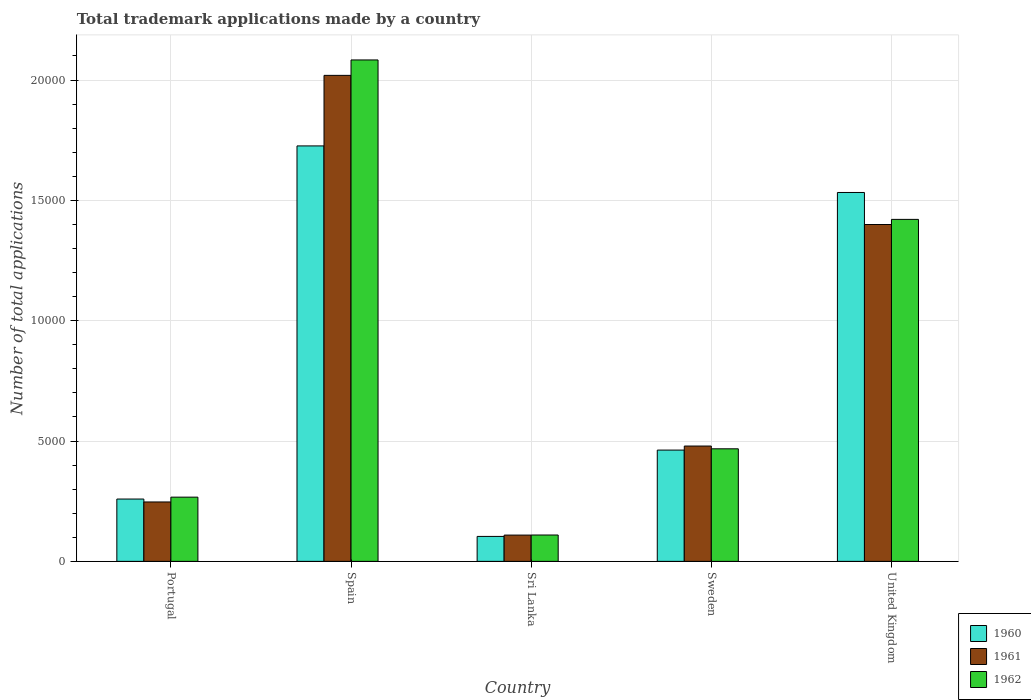Are the number of bars per tick equal to the number of legend labels?
Offer a terse response. Yes. Are the number of bars on each tick of the X-axis equal?
Your response must be concise. Yes. How many bars are there on the 2nd tick from the left?
Make the answer very short. 3. How many bars are there on the 1st tick from the right?
Ensure brevity in your answer.  3. What is the label of the 4th group of bars from the left?
Ensure brevity in your answer.  Sweden. In how many cases, is the number of bars for a given country not equal to the number of legend labels?
Your answer should be compact. 0. What is the number of applications made by in 1960 in Spain?
Keep it short and to the point. 1.73e+04. Across all countries, what is the maximum number of applications made by in 1961?
Your response must be concise. 2.02e+04. Across all countries, what is the minimum number of applications made by in 1962?
Provide a succinct answer. 1095. In which country was the number of applications made by in 1962 minimum?
Provide a short and direct response. Sri Lanka. What is the total number of applications made by in 1962 in the graph?
Offer a terse response. 4.35e+04. What is the difference between the number of applications made by in 1961 in Portugal and that in Spain?
Your answer should be very brief. -1.77e+04. What is the difference between the number of applications made by in 1960 in Sri Lanka and the number of applications made by in 1962 in United Kingdom?
Your answer should be very brief. -1.32e+04. What is the average number of applications made by in 1962 per country?
Provide a short and direct response. 8697. What is the difference between the number of applications made by of/in 1960 and number of applications made by of/in 1961 in United Kingdom?
Your response must be concise. 1331. What is the ratio of the number of applications made by in 1960 in Spain to that in Sri Lanka?
Provide a short and direct response. 16.65. Is the number of applications made by in 1961 in Spain less than that in Sweden?
Provide a short and direct response. No. Is the difference between the number of applications made by in 1960 in Spain and Sri Lanka greater than the difference between the number of applications made by in 1961 in Spain and Sri Lanka?
Offer a terse response. No. What is the difference between the highest and the second highest number of applications made by in 1960?
Give a very brief answer. 1.07e+04. What is the difference between the highest and the lowest number of applications made by in 1960?
Offer a terse response. 1.62e+04. In how many countries, is the number of applications made by in 1962 greater than the average number of applications made by in 1962 taken over all countries?
Your answer should be compact. 2. What does the 2nd bar from the left in United Kingdom represents?
Provide a short and direct response. 1961. What does the 1st bar from the right in Sweden represents?
Make the answer very short. 1962. Is it the case that in every country, the sum of the number of applications made by in 1962 and number of applications made by in 1961 is greater than the number of applications made by in 1960?
Your answer should be very brief. Yes. Are all the bars in the graph horizontal?
Make the answer very short. No. How many countries are there in the graph?
Your answer should be compact. 5. What is the difference between two consecutive major ticks on the Y-axis?
Provide a short and direct response. 5000. Does the graph contain any zero values?
Your answer should be compact. No. Where does the legend appear in the graph?
Give a very brief answer. Bottom right. How many legend labels are there?
Keep it short and to the point. 3. How are the legend labels stacked?
Provide a succinct answer. Vertical. What is the title of the graph?
Your answer should be very brief. Total trademark applications made by a country. What is the label or title of the Y-axis?
Provide a succinct answer. Number of total applications. What is the Number of total applications of 1960 in Portugal?
Provide a succinct answer. 2590. What is the Number of total applications in 1961 in Portugal?
Offer a very short reply. 2468. What is the Number of total applications of 1962 in Portugal?
Provide a short and direct response. 2668. What is the Number of total applications of 1960 in Spain?
Provide a short and direct response. 1.73e+04. What is the Number of total applications of 1961 in Spain?
Make the answer very short. 2.02e+04. What is the Number of total applications of 1962 in Spain?
Keep it short and to the point. 2.08e+04. What is the Number of total applications of 1960 in Sri Lanka?
Offer a terse response. 1037. What is the Number of total applications of 1961 in Sri Lanka?
Your answer should be very brief. 1092. What is the Number of total applications in 1962 in Sri Lanka?
Your answer should be very brief. 1095. What is the Number of total applications of 1960 in Sweden?
Keep it short and to the point. 4624. What is the Number of total applications of 1961 in Sweden?
Give a very brief answer. 4792. What is the Number of total applications of 1962 in Sweden?
Keep it short and to the point. 4677. What is the Number of total applications of 1960 in United Kingdom?
Keep it short and to the point. 1.53e+04. What is the Number of total applications in 1961 in United Kingdom?
Give a very brief answer. 1.40e+04. What is the Number of total applications of 1962 in United Kingdom?
Your response must be concise. 1.42e+04. Across all countries, what is the maximum Number of total applications in 1960?
Give a very brief answer. 1.73e+04. Across all countries, what is the maximum Number of total applications of 1961?
Provide a short and direct response. 2.02e+04. Across all countries, what is the maximum Number of total applications in 1962?
Ensure brevity in your answer.  2.08e+04. Across all countries, what is the minimum Number of total applications of 1960?
Make the answer very short. 1037. Across all countries, what is the minimum Number of total applications in 1961?
Your answer should be compact. 1092. Across all countries, what is the minimum Number of total applications of 1962?
Keep it short and to the point. 1095. What is the total Number of total applications of 1960 in the graph?
Ensure brevity in your answer.  4.08e+04. What is the total Number of total applications of 1961 in the graph?
Make the answer very short. 4.25e+04. What is the total Number of total applications in 1962 in the graph?
Your response must be concise. 4.35e+04. What is the difference between the Number of total applications of 1960 in Portugal and that in Spain?
Offer a terse response. -1.47e+04. What is the difference between the Number of total applications in 1961 in Portugal and that in Spain?
Make the answer very short. -1.77e+04. What is the difference between the Number of total applications in 1962 in Portugal and that in Spain?
Keep it short and to the point. -1.82e+04. What is the difference between the Number of total applications of 1960 in Portugal and that in Sri Lanka?
Your response must be concise. 1553. What is the difference between the Number of total applications of 1961 in Portugal and that in Sri Lanka?
Keep it short and to the point. 1376. What is the difference between the Number of total applications in 1962 in Portugal and that in Sri Lanka?
Keep it short and to the point. 1573. What is the difference between the Number of total applications of 1960 in Portugal and that in Sweden?
Give a very brief answer. -2034. What is the difference between the Number of total applications in 1961 in Portugal and that in Sweden?
Keep it short and to the point. -2324. What is the difference between the Number of total applications of 1962 in Portugal and that in Sweden?
Provide a short and direct response. -2009. What is the difference between the Number of total applications of 1960 in Portugal and that in United Kingdom?
Provide a succinct answer. -1.27e+04. What is the difference between the Number of total applications of 1961 in Portugal and that in United Kingdom?
Give a very brief answer. -1.15e+04. What is the difference between the Number of total applications of 1962 in Portugal and that in United Kingdom?
Make the answer very short. -1.15e+04. What is the difference between the Number of total applications in 1960 in Spain and that in Sri Lanka?
Your response must be concise. 1.62e+04. What is the difference between the Number of total applications of 1961 in Spain and that in Sri Lanka?
Make the answer very short. 1.91e+04. What is the difference between the Number of total applications of 1962 in Spain and that in Sri Lanka?
Keep it short and to the point. 1.97e+04. What is the difference between the Number of total applications in 1960 in Spain and that in Sweden?
Offer a very short reply. 1.26e+04. What is the difference between the Number of total applications in 1961 in Spain and that in Sweden?
Ensure brevity in your answer.  1.54e+04. What is the difference between the Number of total applications in 1962 in Spain and that in Sweden?
Ensure brevity in your answer.  1.62e+04. What is the difference between the Number of total applications of 1960 in Spain and that in United Kingdom?
Your answer should be very brief. 1935. What is the difference between the Number of total applications in 1961 in Spain and that in United Kingdom?
Offer a very short reply. 6197. What is the difference between the Number of total applications of 1962 in Spain and that in United Kingdom?
Your response must be concise. 6625. What is the difference between the Number of total applications of 1960 in Sri Lanka and that in Sweden?
Provide a succinct answer. -3587. What is the difference between the Number of total applications of 1961 in Sri Lanka and that in Sweden?
Provide a succinct answer. -3700. What is the difference between the Number of total applications in 1962 in Sri Lanka and that in Sweden?
Your answer should be very brief. -3582. What is the difference between the Number of total applications in 1960 in Sri Lanka and that in United Kingdom?
Provide a succinct answer. -1.43e+04. What is the difference between the Number of total applications of 1961 in Sri Lanka and that in United Kingdom?
Give a very brief answer. -1.29e+04. What is the difference between the Number of total applications of 1962 in Sri Lanka and that in United Kingdom?
Your response must be concise. -1.31e+04. What is the difference between the Number of total applications in 1960 in Sweden and that in United Kingdom?
Offer a very short reply. -1.07e+04. What is the difference between the Number of total applications in 1961 in Sweden and that in United Kingdom?
Ensure brevity in your answer.  -9205. What is the difference between the Number of total applications in 1962 in Sweden and that in United Kingdom?
Ensure brevity in your answer.  -9533. What is the difference between the Number of total applications in 1960 in Portugal and the Number of total applications in 1961 in Spain?
Provide a short and direct response. -1.76e+04. What is the difference between the Number of total applications in 1960 in Portugal and the Number of total applications in 1962 in Spain?
Your response must be concise. -1.82e+04. What is the difference between the Number of total applications of 1961 in Portugal and the Number of total applications of 1962 in Spain?
Give a very brief answer. -1.84e+04. What is the difference between the Number of total applications of 1960 in Portugal and the Number of total applications of 1961 in Sri Lanka?
Make the answer very short. 1498. What is the difference between the Number of total applications in 1960 in Portugal and the Number of total applications in 1962 in Sri Lanka?
Provide a succinct answer. 1495. What is the difference between the Number of total applications in 1961 in Portugal and the Number of total applications in 1962 in Sri Lanka?
Give a very brief answer. 1373. What is the difference between the Number of total applications of 1960 in Portugal and the Number of total applications of 1961 in Sweden?
Make the answer very short. -2202. What is the difference between the Number of total applications in 1960 in Portugal and the Number of total applications in 1962 in Sweden?
Provide a short and direct response. -2087. What is the difference between the Number of total applications in 1961 in Portugal and the Number of total applications in 1962 in Sweden?
Give a very brief answer. -2209. What is the difference between the Number of total applications in 1960 in Portugal and the Number of total applications in 1961 in United Kingdom?
Keep it short and to the point. -1.14e+04. What is the difference between the Number of total applications in 1960 in Portugal and the Number of total applications in 1962 in United Kingdom?
Provide a succinct answer. -1.16e+04. What is the difference between the Number of total applications in 1961 in Portugal and the Number of total applications in 1962 in United Kingdom?
Keep it short and to the point. -1.17e+04. What is the difference between the Number of total applications in 1960 in Spain and the Number of total applications in 1961 in Sri Lanka?
Ensure brevity in your answer.  1.62e+04. What is the difference between the Number of total applications in 1960 in Spain and the Number of total applications in 1962 in Sri Lanka?
Your response must be concise. 1.62e+04. What is the difference between the Number of total applications in 1961 in Spain and the Number of total applications in 1962 in Sri Lanka?
Offer a very short reply. 1.91e+04. What is the difference between the Number of total applications in 1960 in Spain and the Number of total applications in 1961 in Sweden?
Provide a short and direct response. 1.25e+04. What is the difference between the Number of total applications of 1960 in Spain and the Number of total applications of 1962 in Sweden?
Your answer should be compact. 1.26e+04. What is the difference between the Number of total applications of 1961 in Spain and the Number of total applications of 1962 in Sweden?
Provide a short and direct response. 1.55e+04. What is the difference between the Number of total applications in 1960 in Spain and the Number of total applications in 1961 in United Kingdom?
Keep it short and to the point. 3266. What is the difference between the Number of total applications of 1960 in Spain and the Number of total applications of 1962 in United Kingdom?
Ensure brevity in your answer.  3053. What is the difference between the Number of total applications in 1961 in Spain and the Number of total applications in 1962 in United Kingdom?
Give a very brief answer. 5984. What is the difference between the Number of total applications in 1960 in Sri Lanka and the Number of total applications in 1961 in Sweden?
Provide a succinct answer. -3755. What is the difference between the Number of total applications of 1960 in Sri Lanka and the Number of total applications of 1962 in Sweden?
Provide a succinct answer. -3640. What is the difference between the Number of total applications in 1961 in Sri Lanka and the Number of total applications in 1962 in Sweden?
Ensure brevity in your answer.  -3585. What is the difference between the Number of total applications of 1960 in Sri Lanka and the Number of total applications of 1961 in United Kingdom?
Provide a short and direct response. -1.30e+04. What is the difference between the Number of total applications of 1960 in Sri Lanka and the Number of total applications of 1962 in United Kingdom?
Your answer should be very brief. -1.32e+04. What is the difference between the Number of total applications of 1961 in Sri Lanka and the Number of total applications of 1962 in United Kingdom?
Give a very brief answer. -1.31e+04. What is the difference between the Number of total applications of 1960 in Sweden and the Number of total applications of 1961 in United Kingdom?
Offer a very short reply. -9373. What is the difference between the Number of total applications of 1960 in Sweden and the Number of total applications of 1962 in United Kingdom?
Offer a terse response. -9586. What is the difference between the Number of total applications in 1961 in Sweden and the Number of total applications in 1962 in United Kingdom?
Make the answer very short. -9418. What is the average Number of total applications of 1960 per country?
Ensure brevity in your answer.  8168.4. What is the average Number of total applications of 1961 per country?
Give a very brief answer. 8508.6. What is the average Number of total applications in 1962 per country?
Your response must be concise. 8697. What is the difference between the Number of total applications in 1960 and Number of total applications in 1961 in Portugal?
Provide a short and direct response. 122. What is the difference between the Number of total applications in 1960 and Number of total applications in 1962 in Portugal?
Ensure brevity in your answer.  -78. What is the difference between the Number of total applications in 1961 and Number of total applications in 1962 in Portugal?
Provide a short and direct response. -200. What is the difference between the Number of total applications in 1960 and Number of total applications in 1961 in Spain?
Your answer should be compact. -2931. What is the difference between the Number of total applications of 1960 and Number of total applications of 1962 in Spain?
Provide a short and direct response. -3572. What is the difference between the Number of total applications of 1961 and Number of total applications of 1962 in Spain?
Your answer should be compact. -641. What is the difference between the Number of total applications in 1960 and Number of total applications in 1961 in Sri Lanka?
Ensure brevity in your answer.  -55. What is the difference between the Number of total applications in 1960 and Number of total applications in 1962 in Sri Lanka?
Offer a terse response. -58. What is the difference between the Number of total applications in 1960 and Number of total applications in 1961 in Sweden?
Provide a short and direct response. -168. What is the difference between the Number of total applications of 1960 and Number of total applications of 1962 in Sweden?
Give a very brief answer. -53. What is the difference between the Number of total applications in 1961 and Number of total applications in 1962 in Sweden?
Offer a terse response. 115. What is the difference between the Number of total applications in 1960 and Number of total applications in 1961 in United Kingdom?
Your answer should be compact. 1331. What is the difference between the Number of total applications in 1960 and Number of total applications in 1962 in United Kingdom?
Your response must be concise. 1118. What is the difference between the Number of total applications of 1961 and Number of total applications of 1962 in United Kingdom?
Your answer should be compact. -213. What is the ratio of the Number of total applications in 1961 in Portugal to that in Spain?
Your answer should be very brief. 0.12. What is the ratio of the Number of total applications of 1962 in Portugal to that in Spain?
Offer a terse response. 0.13. What is the ratio of the Number of total applications of 1960 in Portugal to that in Sri Lanka?
Offer a terse response. 2.5. What is the ratio of the Number of total applications of 1961 in Portugal to that in Sri Lanka?
Ensure brevity in your answer.  2.26. What is the ratio of the Number of total applications in 1962 in Portugal to that in Sri Lanka?
Keep it short and to the point. 2.44. What is the ratio of the Number of total applications of 1960 in Portugal to that in Sweden?
Ensure brevity in your answer.  0.56. What is the ratio of the Number of total applications in 1961 in Portugal to that in Sweden?
Your answer should be compact. 0.52. What is the ratio of the Number of total applications of 1962 in Portugal to that in Sweden?
Make the answer very short. 0.57. What is the ratio of the Number of total applications in 1960 in Portugal to that in United Kingdom?
Ensure brevity in your answer.  0.17. What is the ratio of the Number of total applications in 1961 in Portugal to that in United Kingdom?
Your answer should be compact. 0.18. What is the ratio of the Number of total applications of 1962 in Portugal to that in United Kingdom?
Provide a short and direct response. 0.19. What is the ratio of the Number of total applications of 1960 in Spain to that in Sri Lanka?
Offer a terse response. 16.65. What is the ratio of the Number of total applications of 1961 in Spain to that in Sri Lanka?
Keep it short and to the point. 18.49. What is the ratio of the Number of total applications in 1962 in Spain to that in Sri Lanka?
Make the answer very short. 19.03. What is the ratio of the Number of total applications of 1960 in Spain to that in Sweden?
Ensure brevity in your answer.  3.73. What is the ratio of the Number of total applications in 1961 in Spain to that in Sweden?
Your answer should be compact. 4.21. What is the ratio of the Number of total applications of 1962 in Spain to that in Sweden?
Offer a terse response. 4.45. What is the ratio of the Number of total applications of 1960 in Spain to that in United Kingdom?
Ensure brevity in your answer.  1.13. What is the ratio of the Number of total applications of 1961 in Spain to that in United Kingdom?
Provide a succinct answer. 1.44. What is the ratio of the Number of total applications of 1962 in Spain to that in United Kingdom?
Provide a succinct answer. 1.47. What is the ratio of the Number of total applications in 1960 in Sri Lanka to that in Sweden?
Your answer should be compact. 0.22. What is the ratio of the Number of total applications in 1961 in Sri Lanka to that in Sweden?
Your answer should be compact. 0.23. What is the ratio of the Number of total applications in 1962 in Sri Lanka to that in Sweden?
Your response must be concise. 0.23. What is the ratio of the Number of total applications in 1960 in Sri Lanka to that in United Kingdom?
Provide a short and direct response. 0.07. What is the ratio of the Number of total applications in 1961 in Sri Lanka to that in United Kingdom?
Your answer should be very brief. 0.08. What is the ratio of the Number of total applications of 1962 in Sri Lanka to that in United Kingdom?
Ensure brevity in your answer.  0.08. What is the ratio of the Number of total applications of 1960 in Sweden to that in United Kingdom?
Your response must be concise. 0.3. What is the ratio of the Number of total applications of 1961 in Sweden to that in United Kingdom?
Give a very brief answer. 0.34. What is the ratio of the Number of total applications of 1962 in Sweden to that in United Kingdom?
Give a very brief answer. 0.33. What is the difference between the highest and the second highest Number of total applications in 1960?
Your response must be concise. 1935. What is the difference between the highest and the second highest Number of total applications in 1961?
Your answer should be compact. 6197. What is the difference between the highest and the second highest Number of total applications of 1962?
Your answer should be very brief. 6625. What is the difference between the highest and the lowest Number of total applications of 1960?
Make the answer very short. 1.62e+04. What is the difference between the highest and the lowest Number of total applications of 1961?
Offer a terse response. 1.91e+04. What is the difference between the highest and the lowest Number of total applications in 1962?
Your answer should be very brief. 1.97e+04. 